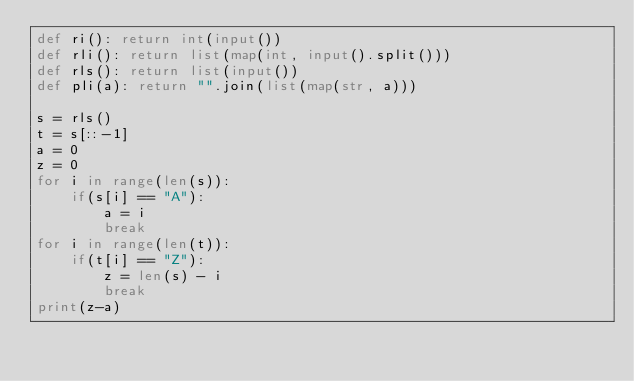Convert code to text. <code><loc_0><loc_0><loc_500><loc_500><_Python_>def ri(): return int(input())
def rli(): return list(map(int, input().split()))
def rls(): return list(input())
def pli(a): return "".join(list(map(str, a)))

s = rls()
t = s[::-1]
a = 0
z = 0
for i in range(len(s)):
    if(s[i] == "A"):
        a = i
        break
for i in range(len(t)):
    if(t[i] == "Z"):
        z = len(s) - i
        break
print(z-a)</code> 